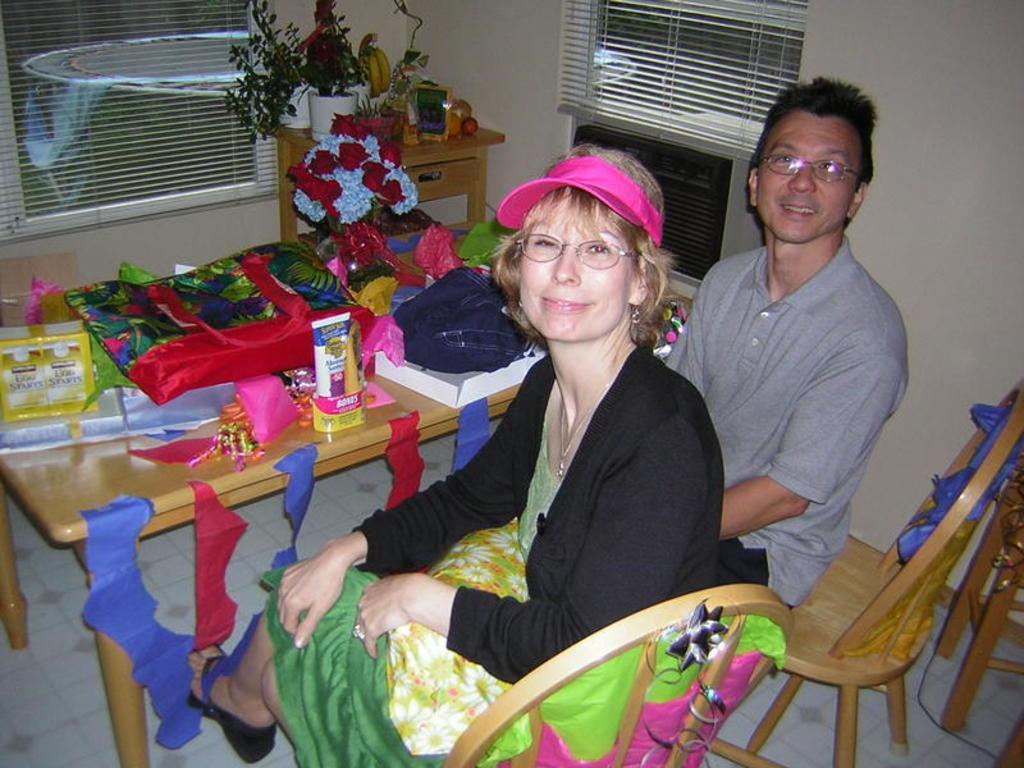Please provide a concise description of this image. Bottom right side of the image two persons are sitting on a chair and they are smiling. In front of them there is a table on the table there are some bags and there are some products. In the middle of the image there is a table on the table there are some plants, fruits. Top left side of the image there is a window. Through the window we can see some table. 